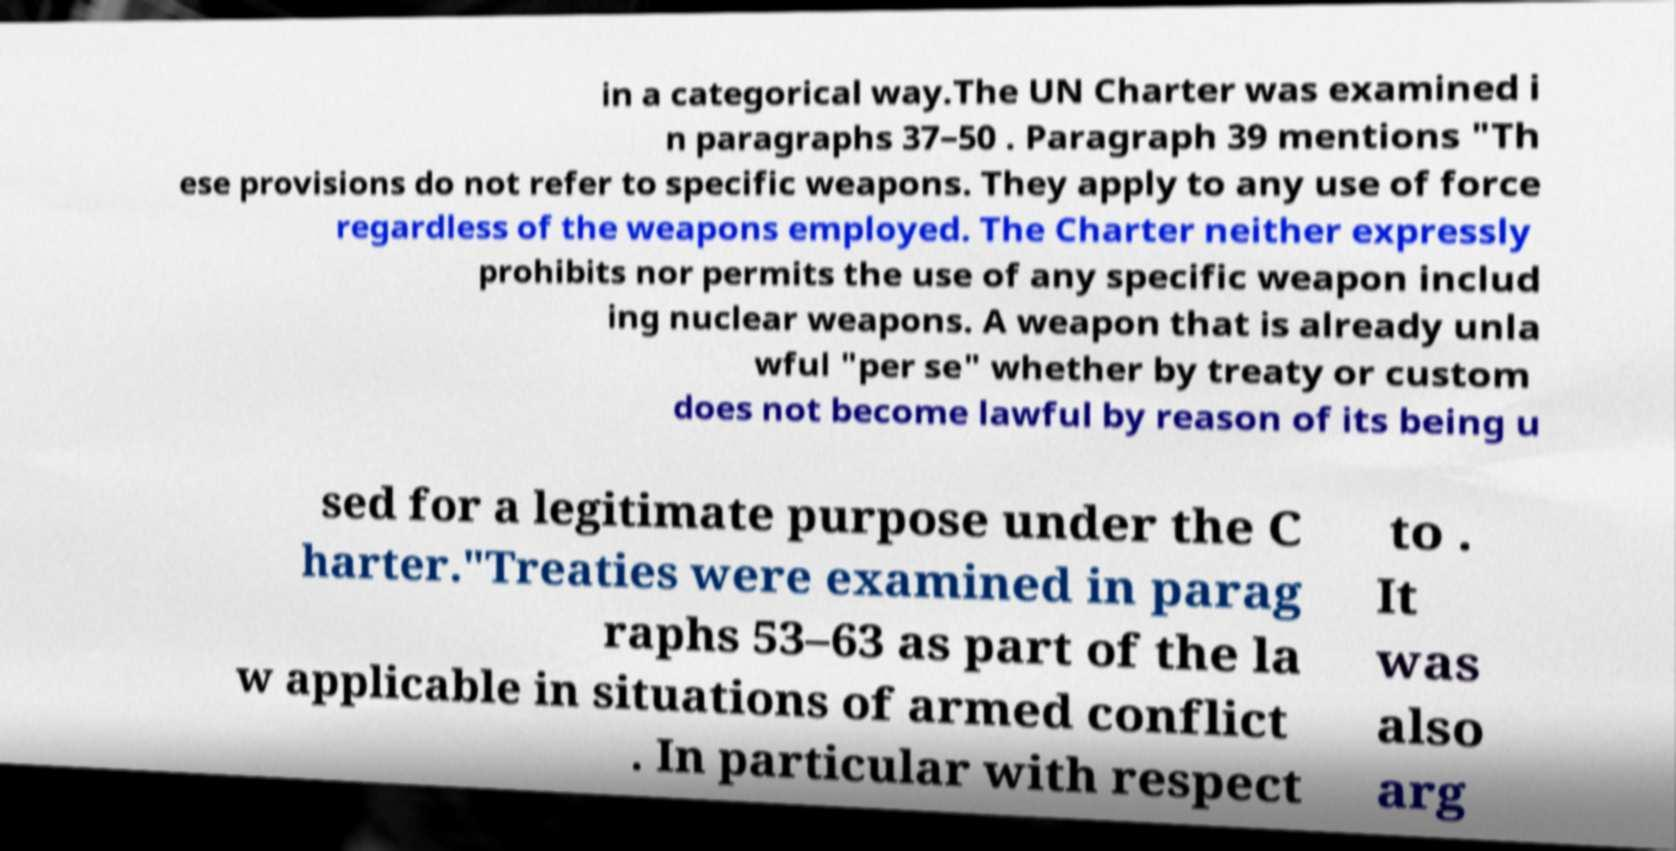Can you accurately transcribe the text from the provided image for me? in a categorical way.The UN Charter was examined i n paragraphs 37–50 . Paragraph 39 mentions "Th ese provisions do not refer to specific weapons. They apply to any use of force regardless of the weapons employed. The Charter neither expressly prohibits nor permits the use of any specific weapon includ ing nuclear weapons. A weapon that is already unla wful "per se" whether by treaty or custom does not become lawful by reason of its being u sed for a legitimate purpose under the C harter."Treaties were examined in parag raphs 53–63 as part of the la w applicable in situations of armed conflict . In particular with respect to . It was also arg 